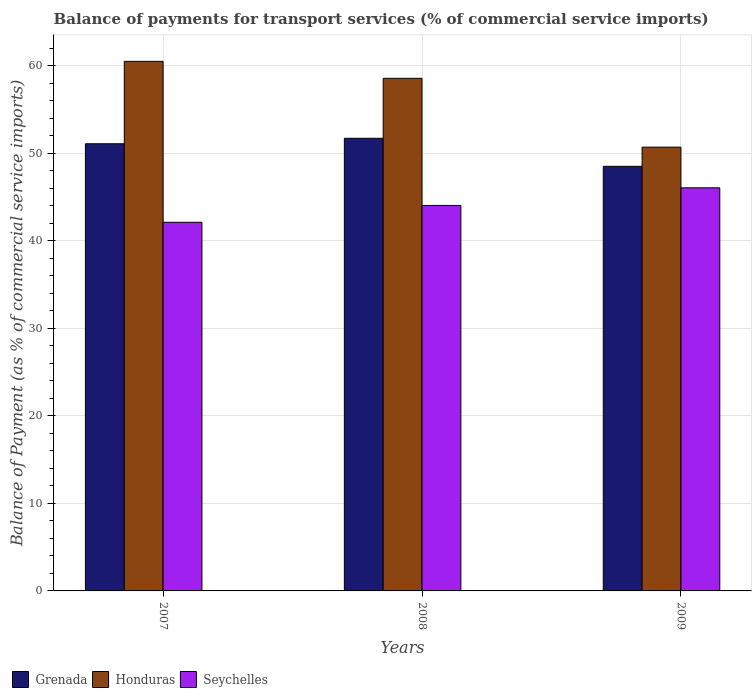Are the number of bars on each tick of the X-axis equal?
Your answer should be compact. Yes. What is the balance of payments for transport services in Seychelles in 2009?
Give a very brief answer. 46.04. Across all years, what is the maximum balance of payments for transport services in Honduras?
Offer a terse response. 60.48. Across all years, what is the minimum balance of payments for transport services in Grenada?
Make the answer very short. 48.5. In which year was the balance of payments for transport services in Grenada maximum?
Offer a very short reply. 2008. What is the total balance of payments for transport services in Seychelles in the graph?
Offer a very short reply. 132.16. What is the difference between the balance of payments for transport services in Seychelles in 2007 and that in 2008?
Provide a short and direct response. -1.92. What is the difference between the balance of payments for transport services in Grenada in 2007 and the balance of payments for transport services in Honduras in 2009?
Provide a short and direct response. 0.39. What is the average balance of payments for transport services in Honduras per year?
Offer a terse response. 56.57. In the year 2008, what is the difference between the balance of payments for transport services in Grenada and balance of payments for transport services in Seychelles?
Ensure brevity in your answer.  7.67. In how many years, is the balance of payments for transport services in Grenada greater than 14 %?
Provide a succinct answer. 3. What is the ratio of the balance of payments for transport services in Seychelles in 2007 to that in 2009?
Your response must be concise. 0.91. Is the balance of payments for transport services in Grenada in 2007 less than that in 2008?
Ensure brevity in your answer.  Yes. Is the difference between the balance of payments for transport services in Grenada in 2007 and 2008 greater than the difference between the balance of payments for transport services in Seychelles in 2007 and 2008?
Offer a very short reply. Yes. What is the difference between the highest and the second highest balance of payments for transport services in Seychelles?
Offer a terse response. 2.01. What is the difference between the highest and the lowest balance of payments for transport services in Seychelles?
Offer a terse response. 3.94. In how many years, is the balance of payments for transport services in Honduras greater than the average balance of payments for transport services in Honduras taken over all years?
Your answer should be compact. 2. What does the 1st bar from the left in 2009 represents?
Your answer should be compact. Grenada. What does the 2nd bar from the right in 2007 represents?
Provide a short and direct response. Honduras. Is it the case that in every year, the sum of the balance of payments for transport services in Grenada and balance of payments for transport services in Honduras is greater than the balance of payments for transport services in Seychelles?
Offer a terse response. Yes. How many bars are there?
Provide a succinct answer. 9. Are all the bars in the graph horizontal?
Your answer should be very brief. No. How many years are there in the graph?
Offer a terse response. 3. Does the graph contain grids?
Ensure brevity in your answer.  Yes. How are the legend labels stacked?
Provide a succinct answer. Horizontal. What is the title of the graph?
Your answer should be very brief. Balance of payments for transport services (% of commercial service imports). Does "New Caledonia" appear as one of the legend labels in the graph?
Give a very brief answer. No. What is the label or title of the Y-axis?
Your response must be concise. Balance of Payment (as % of commercial service imports). What is the Balance of Payment (as % of commercial service imports) of Grenada in 2007?
Keep it short and to the point. 51.07. What is the Balance of Payment (as % of commercial service imports) in Honduras in 2007?
Keep it short and to the point. 60.48. What is the Balance of Payment (as % of commercial service imports) in Seychelles in 2007?
Ensure brevity in your answer.  42.1. What is the Balance of Payment (as % of commercial service imports) in Grenada in 2008?
Your response must be concise. 51.69. What is the Balance of Payment (as % of commercial service imports) in Honduras in 2008?
Make the answer very short. 58.54. What is the Balance of Payment (as % of commercial service imports) of Seychelles in 2008?
Give a very brief answer. 44.02. What is the Balance of Payment (as % of commercial service imports) in Grenada in 2009?
Your answer should be very brief. 48.5. What is the Balance of Payment (as % of commercial service imports) of Honduras in 2009?
Offer a very short reply. 50.68. What is the Balance of Payment (as % of commercial service imports) of Seychelles in 2009?
Offer a very short reply. 46.04. Across all years, what is the maximum Balance of Payment (as % of commercial service imports) of Grenada?
Offer a terse response. 51.69. Across all years, what is the maximum Balance of Payment (as % of commercial service imports) of Honduras?
Provide a succinct answer. 60.48. Across all years, what is the maximum Balance of Payment (as % of commercial service imports) of Seychelles?
Your response must be concise. 46.04. Across all years, what is the minimum Balance of Payment (as % of commercial service imports) of Grenada?
Offer a terse response. 48.5. Across all years, what is the minimum Balance of Payment (as % of commercial service imports) of Honduras?
Ensure brevity in your answer.  50.68. Across all years, what is the minimum Balance of Payment (as % of commercial service imports) in Seychelles?
Your answer should be very brief. 42.1. What is the total Balance of Payment (as % of commercial service imports) of Grenada in the graph?
Your answer should be compact. 151.26. What is the total Balance of Payment (as % of commercial service imports) in Honduras in the graph?
Keep it short and to the point. 169.7. What is the total Balance of Payment (as % of commercial service imports) of Seychelles in the graph?
Make the answer very short. 132.16. What is the difference between the Balance of Payment (as % of commercial service imports) in Grenada in 2007 and that in 2008?
Keep it short and to the point. -0.62. What is the difference between the Balance of Payment (as % of commercial service imports) in Honduras in 2007 and that in 2008?
Offer a very short reply. 1.94. What is the difference between the Balance of Payment (as % of commercial service imports) in Seychelles in 2007 and that in 2008?
Give a very brief answer. -1.92. What is the difference between the Balance of Payment (as % of commercial service imports) in Grenada in 2007 and that in 2009?
Your answer should be very brief. 2.57. What is the difference between the Balance of Payment (as % of commercial service imports) of Honduras in 2007 and that in 2009?
Ensure brevity in your answer.  9.8. What is the difference between the Balance of Payment (as % of commercial service imports) of Seychelles in 2007 and that in 2009?
Provide a short and direct response. -3.94. What is the difference between the Balance of Payment (as % of commercial service imports) of Grenada in 2008 and that in 2009?
Your answer should be very brief. 3.2. What is the difference between the Balance of Payment (as % of commercial service imports) in Honduras in 2008 and that in 2009?
Your response must be concise. 7.86. What is the difference between the Balance of Payment (as % of commercial service imports) of Seychelles in 2008 and that in 2009?
Give a very brief answer. -2.01. What is the difference between the Balance of Payment (as % of commercial service imports) of Grenada in 2007 and the Balance of Payment (as % of commercial service imports) of Honduras in 2008?
Make the answer very short. -7.47. What is the difference between the Balance of Payment (as % of commercial service imports) of Grenada in 2007 and the Balance of Payment (as % of commercial service imports) of Seychelles in 2008?
Give a very brief answer. 7.05. What is the difference between the Balance of Payment (as % of commercial service imports) in Honduras in 2007 and the Balance of Payment (as % of commercial service imports) in Seychelles in 2008?
Ensure brevity in your answer.  16.46. What is the difference between the Balance of Payment (as % of commercial service imports) of Grenada in 2007 and the Balance of Payment (as % of commercial service imports) of Honduras in 2009?
Your answer should be very brief. 0.39. What is the difference between the Balance of Payment (as % of commercial service imports) in Grenada in 2007 and the Balance of Payment (as % of commercial service imports) in Seychelles in 2009?
Your answer should be compact. 5.03. What is the difference between the Balance of Payment (as % of commercial service imports) in Honduras in 2007 and the Balance of Payment (as % of commercial service imports) in Seychelles in 2009?
Keep it short and to the point. 14.44. What is the difference between the Balance of Payment (as % of commercial service imports) in Grenada in 2008 and the Balance of Payment (as % of commercial service imports) in Honduras in 2009?
Provide a succinct answer. 1.01. What is the difference between the Balance of Payment (as % of commercial service imports) in Grenada in 2008 and the Balance of Payment (as % of commercial service imports) in Seychelles in 2009?
Ensure brevity in your answer.  5.66. What is the difference between the Balance of Payment (as % of commercial service imports) of Honduras in 2008 and the Balance of Payment (as % of commercial service imports) of Seychelles in 2009?
Make the answer very short. 12.5. What is the average Balance of Payment (as % of commercial service imports) of Grenada per year?
Give a very brief answer. 50.42. What is the average Balance of Payment (as % of commercial service imports) of Honduras per year?
Offer a very short reply. 56.57. What is the average Balance of Payment (as % of commercial service imports) of Seychelles per year?
Keep it short and to the point. 44.05. In the year 2007, what is the difference between the Balance of Payment (as % of commercial service imports) in Grenada and Balance of Payment (as % of commercial service imports) in Honduras?
Your answer should be very brief. -9.41. In the year 2007, what is the difference between the Balance of Payment (as % of commercial service imports) in Grenada and Balance of Payment (as % of commercial service imports) in Seychelles?
Ensure brevity in your answer.  8.97. In the year 2007, what is the difference between the Balance of Payment (as % of commercial service imports) in Honduras and Balance of Payment (as % of commercial service imports) in Seychelles?
Offer a terse response. 18.38. In the year 2008, what is the difference between the Balance of Payment (as % of commercial service imports) in Grenada and Balance of Payment (as % of commercial service imports) in Honduras?
Your answer should be very brief. -6.85. In the year 2008, what is the difference between the Balance of Payment (as % of commercial service imports) in Grenada and Balance of Payment (as % of commercial service imports) in Seychelles?
Give a very brief answer. 7.67. In the year 2008, what is the difference between the Balance of Payment (as % of commercial service imports) of Honduras and Balance of Payment (as % of commercial service imports) of Seychelles?
Give a very brief answer. 14.52. In the year 2009, what is the difference between the Balance of Payment (as % of commercial service imports) in Grenada and Balance of Payment (as % of commercial service imports) in Honduras?
Your answer should be compact. -2.19. In the year 2009, what is the difference between the Balance of Payment (as % of commercial service imports) of Grenada and Balance of Payment (as % of commercial service imports) of Seychelles?
Give a very brief answer. 2.46. In the year 2009, what is the difference between the Balance of Payment (as % of commercial service imports) of Honduras and Balance of Payment (as % of commercial service imports) of Seychelles?
Provide a short and direct response. 4.64. What is the ratio of the Balance of Payment (as % of commercial service imports) of Grenada in 2007 to that in 2008?
Ensure brevity in your answer.  0.99. What is the ratio of the Balance of Payment (as % of commercial service imports) in Honduras in 2007 to that in 2008?
Offer a very short reply. 1.03. What is the ratio of the Balance of Payment (as % of commercial service imports) of Seychelles in 2007 to that in 2008?
Make the answer very short. 0.96. What is the ratio of the Balance of Payment (as % of commercial service imports) of Grenada in 2007 to that in 2009?
Offer a terse response. 1.05. What is the ratio of the Balance of Payment (as % of commercial service imports) of Honduras in 2007 to that in 2009?
Your response must be concise. 1.19. What is the ratio of the Balance of Payment (as % of commercial service imports) in Seychelles in 2007 to that in 2009?
Ensure brevity in your answer.  0.91. What is the ratio of the Balance of Payment (as % of commercial service imports) of Grenada in 2008 to that in 2009?
Offer a very short reply. 1.07. What is the ratio of the Balance of Payment (as % of commercial service imports) of Honduras in 2008 to that in 2009?
Make the answer very short. 1.16. What is the ratio of the Balance of Payment (as % of commercial service imports) of Seychelles in 2008 to that in 2009?
Make the answer very short. 0.96. What is the difference between the highest and the second highest Balance of Payment (as % of commercial service imports) of Grenada?
Provide a short and direct response. 0.62. What is the difference between the highest and the second highest Balance of Payment (as % of commercial service imports) in Honduras?
Your response must be concise. 1.94. What is the difference between the highest and the second highest Balance of Payment (as % of commercial service imports) in Seychelles?
Ensure brevity in your answer.  2.01. What is the difference between the highest and the lowest Balance of Payment (as % of commercial service imports) in Grenada?
Offer a very short reply. 3.2. What is the difference between the highest and the lowest Balance of Payment (as % of commercial service imports) in Honduras?
Make the answer very short. 9.8. What is the difference between the highest and the lowest Balance of Payment (as % of commercial service imports) of Seychelles?
Provide a succinct answer. 3.94. 